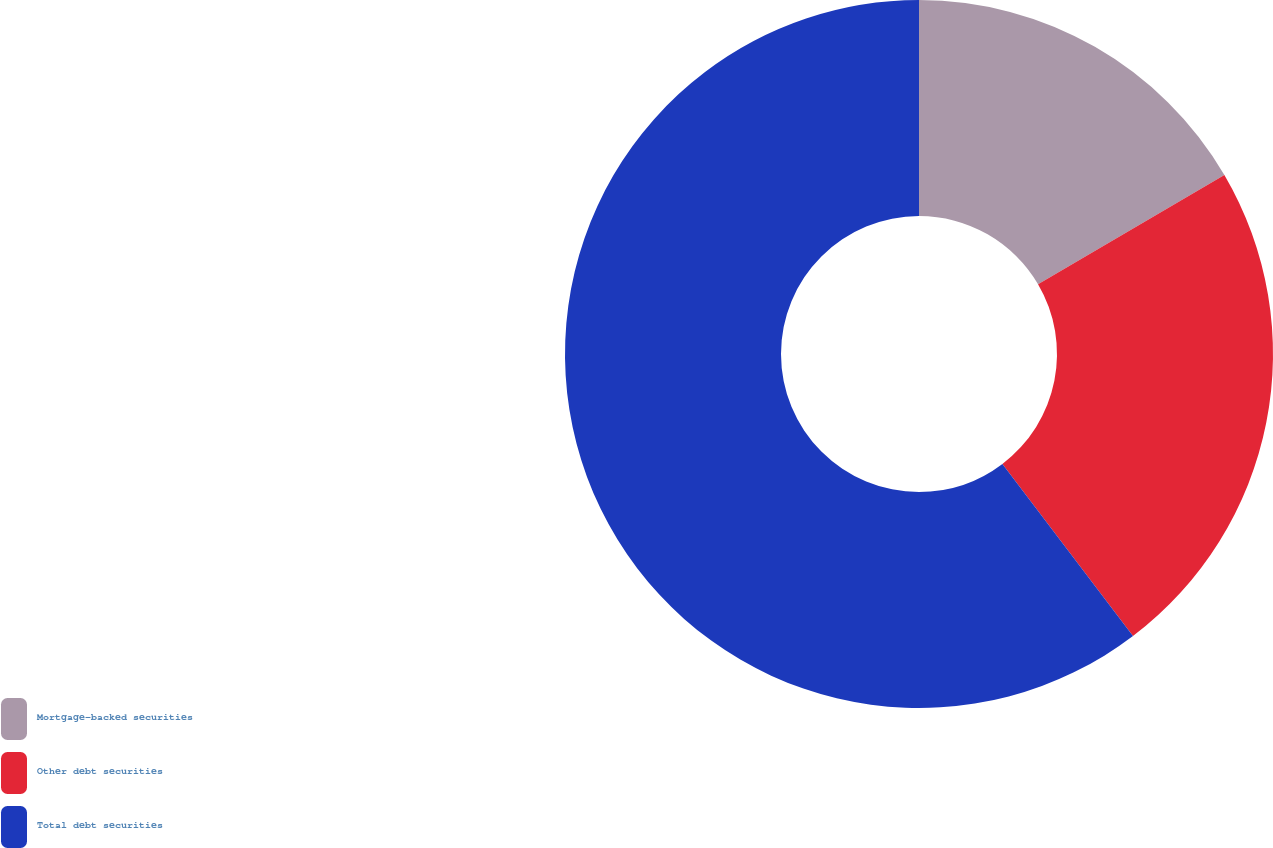Convert chart. <chart><loc_0><loc_0><loc_500><loc_500><pie_chart><fcel>Mortgage-backed securities<fcel>Other debt securities<fcel>Total debt securities<nl><fcel>16.56%<fcel>23.11%<fcel>60.33%<nl></chart> 